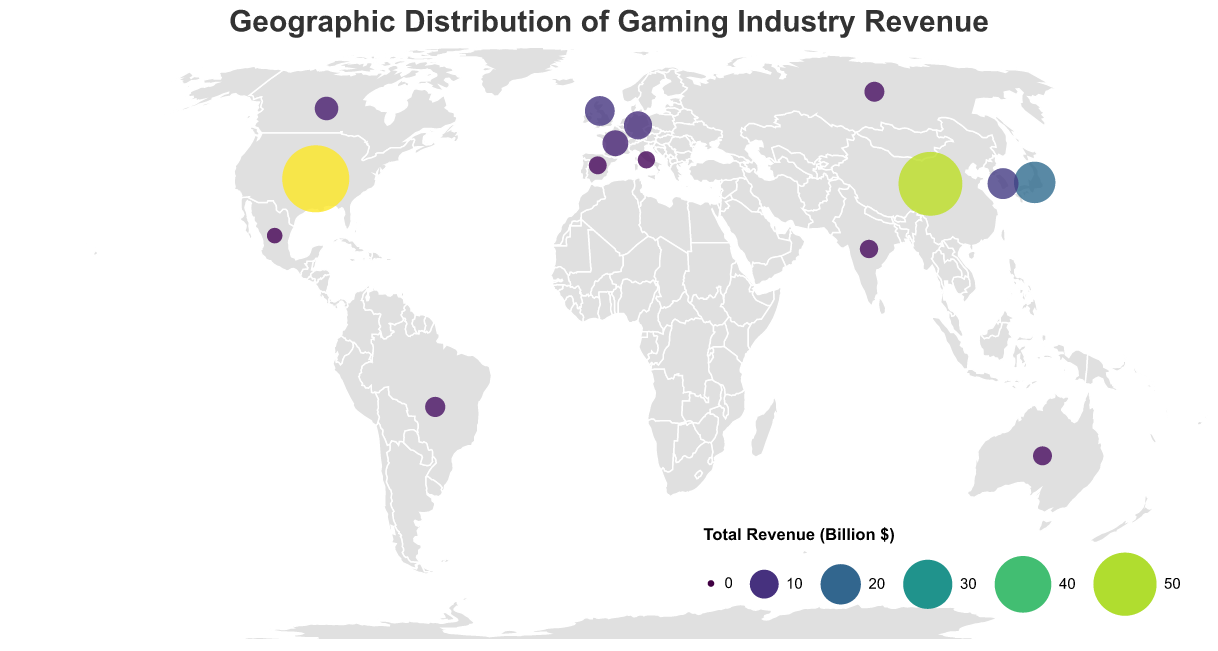Which country has the highest gaming industry revenue? Observing the size and color of the circles, China has the highest total revenue. The tooltip confirmation shows China with a total revenue of 51 billion dollars
Answer: China What is the approximate total gaming revenue for Japan? By hovering over the circle representing Japan, the tooltip shows Japan's total revenue as 21.2 billion dollars
Answer: 21.2 billion dollars Which platform generates the most revenue in the United States? Referring to the tooltip when hovering over the circle for the United States, it shows mobile revenue is 25.6 billion dollars, which is higher than console and PC revenue
Answer: Mobile How does the revenue from consoles in Germany compare to that in the United Kingdom? By examining the tooltips for both Germany and the United Kingdom, Germany has console revenue of 3.8 billion dollars, while the United Kingdom has 4.7 billion dollars
Answer: The United Kingdom has higher console revenue than Germany Which country has the smallest total revenue and how much is it? Comparing the size and color of all circles, Mexico has the smallest size and darkest shade; the tooltip confirms Mexico's total revenue as 2.5 billion dollars
Answer: Mexico, 2.5 billion dollars Calculate the sum of PC gaming revenues for Brazil and Russia. Referring to their tooltips, Brazil's PC revenue is 1.2 billion dollars and Russia's is 1.4 billion dollars. Summing these up gives 1.2 + 1.4 = 2.6
Answer: 2.6 billion dollars Which country generates the least revenue from mobile gaming among the top five countries by total revenue? The top five countries by total revenue are the United States, China, Japan, South Korea, and the United Kingdom. Checking their tooltips: China (30.2), United States (25.6), Japan (11.8), South Korea (5.6), United Kingdom (3.9). The United Kingdom has the lowest mobile revenue among these
Answer: United Kingdom Compare the total gaming revenues of Canada and South Korea. Which is higher and by how much? Referring to their tooltips, Canada's total revenue is 6.5 billion dollars and South Korea's is 11.6 billion dollars. The difference is 11.6 - 6.5 = 5.1 billion dollars
Answer: South Korea, by 5.1 billion dollars What is the average gaming revenue from consoles across all listed countries? Summing up console revenues: 18.4+5.7+6.9+1.2+4.7+3.8+3.3+2.8+1.5+1.3+0.5+1.6+1.4+1.3+0.9=55.3 .
Dividing by the number of countries (15): 55.3 / 15 ≈ 3.69
Answer: 3.69 billion dollars How many countries have more console revenue than PC revenue? Comparing the tooltip values for console and PC revenue:
United States (Console > PC), Japan, United Kingdom, Germany, France, Canada, Australia, Spain, Italy, Mexico.
These are 10 countries
Answer: 10 countries 